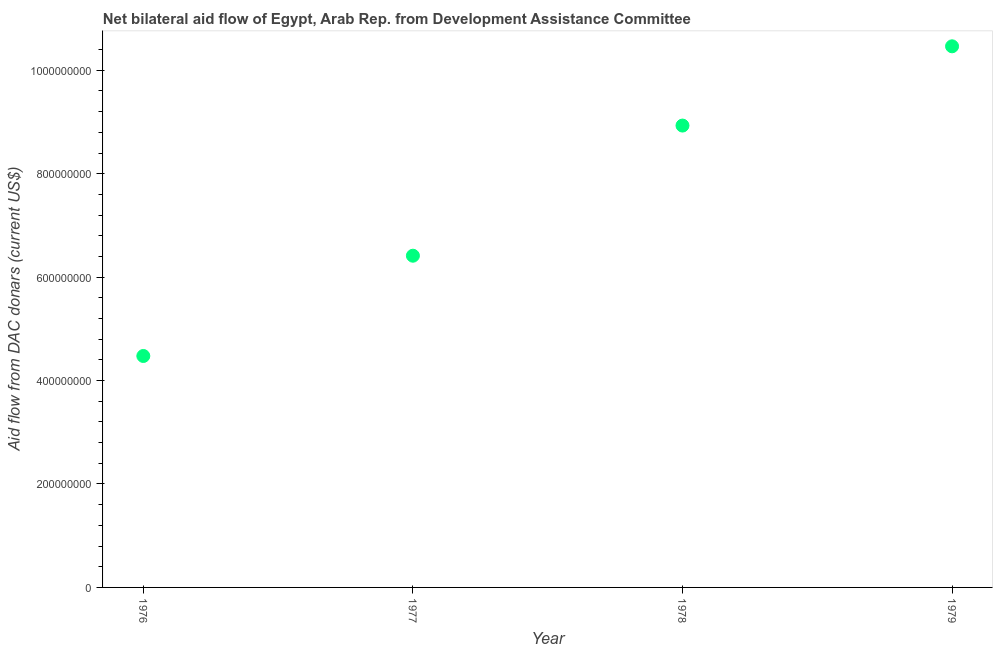What is the net bilateral aid flows from dac donors in 1979?
Provide a short and direct response. 1.05e+09. Across all years, what is the maximum net bilateral aid flows from dac donors?
Provide a succinct answer. 1.05e+09. Across all years, what is the minimum net bilateral aid flows from dac donors?
Offer a very short reply. 4.48e+08. In which year was the net bilateral aid flows from dac donors maximum?
Make the answer very short. 1979. In which year was the net bilateral aid flows from dac donors minimum?
Provide a short and direct response. 1976. What is the sum of the net bilateral aid flows from dac donors?
Your response must be concise. 3.03e+09. What is the difference between the net bilateral aid flows from dac donors in 1978 and 1979?
Provide a short and direct response. -1.53e+08. What is the average net bilateral aid flows from dac donors per year?
Ensure brevity in your answer.  7.57e+08. What is the median net bilateral aid flows from dac donors?
Provide a short and direct response. 7.67e+08. In how many years, is the net bilateral aid flows from dac donors greater than 720000000 US$?
Keep it short and to the point. 2. What is the ratio of the net bilateral aid flows from dac donors in 1977 to that in 1979?
Offer a very short reply. 0.61. Is the net bilateral aid flows from dac donors in 1976 less than that in 1979?
Offer a terse response. Yes. What is the difference between the highest and the second highest net bilateral aid flows from dac donors?
Give a very brief answer. 1.53e+08. What is the difference between the highest and the lowest net bilateral aid flows from dac donors?
Offer a very short reply. 5.99e+08. Does the net bilateral aid flows from dac donors monotonically increase over the years?
Offer a terse response. Yes. How many dotlines are there?
Ensure brevity in your answer.  1. How many years are there in the graph?
Keep it short and to the point. 4. Does the graph contain any zero values?
Your response must be concise. No. Does the graph contain grids?
Make the answer very short. No. What is the title of the graph?
Your answer should be very brief. Net bilateral aid flow of Egypt, Arab Rep. from Development Assistance Committee. What is the label or title of the X-axis?
Your answer should be very brief. Year. What is the label or title of the Y-axis?
Offer a terse response. Aid flow from DAC donars (current US$). What is the Aid flow from DAC donars (current US$) in 1976?
Keep it short and to the point. 4.48e+08. What is the Aid flow from DAC donars (current US$) in 1977?
Keep it short and to the point. 6.41e+08. What is the Aid flow from DAC donars (current US$) in 1978?
Your response must be concise. 8.93e+08. What is the Aid flow from DAC donars (current US$) in 1979?
Provide a short and direct response. 1.05e+09. What is the difference between the Aid flow from DAC donars (current US$) in 1976 and 1977?
Offer a terse response. -1.94e+08. What is the difference between the Aid flow from DAC donars (current US$) in 1976 and 1978?
Your answer should be compact. -4.46e+08. What is the difference between the Aid flow from DAC donars (current US$) in 1976 and 1979?
Keep it short and to the point. -5.99e+08. What is the difference between the Aid flow from DAC donars (current US$) in 1977 and 1978?
Your response must be concise. -2.52e+08. What is the difference between the Aid flow from DAC donars (current US$) in 1977 and 1979?
Make the answer very short. -4.05e+08. What is the difference between the Aid flow from DAC donars (current US$) in 1978 and 1979?
Your response must be concise. -1.53e+08. What is the ratio of the Aid flow from DAC donars (current US$) in 1976 to that in 1977?
Offer a very short reply. 0.7. What is the ratio of the Aid flow from DAC donars (current US$) in 1976 to that in 1978?
Provide a succinct answer. 0.5. What is the ratio of the Aid flow from DAC donars (current US$) in 1976 to that in 1979?
Offer a terse response. 0.43. What is the ratio of the Aid flow from DAC donars (current US$) in 1977 to that in 1978?
Give a very brief answer. 0.72. What is the ratio of the Aid flow from DAC donars (current US$) in 1977 to that in 1979?
Provide a succinct answer. 0.61. What is the ratio of the Aid flow from DAC donars (current US$) in 1978 to that in 1979?
Provide a succinct answer. 0.85. 